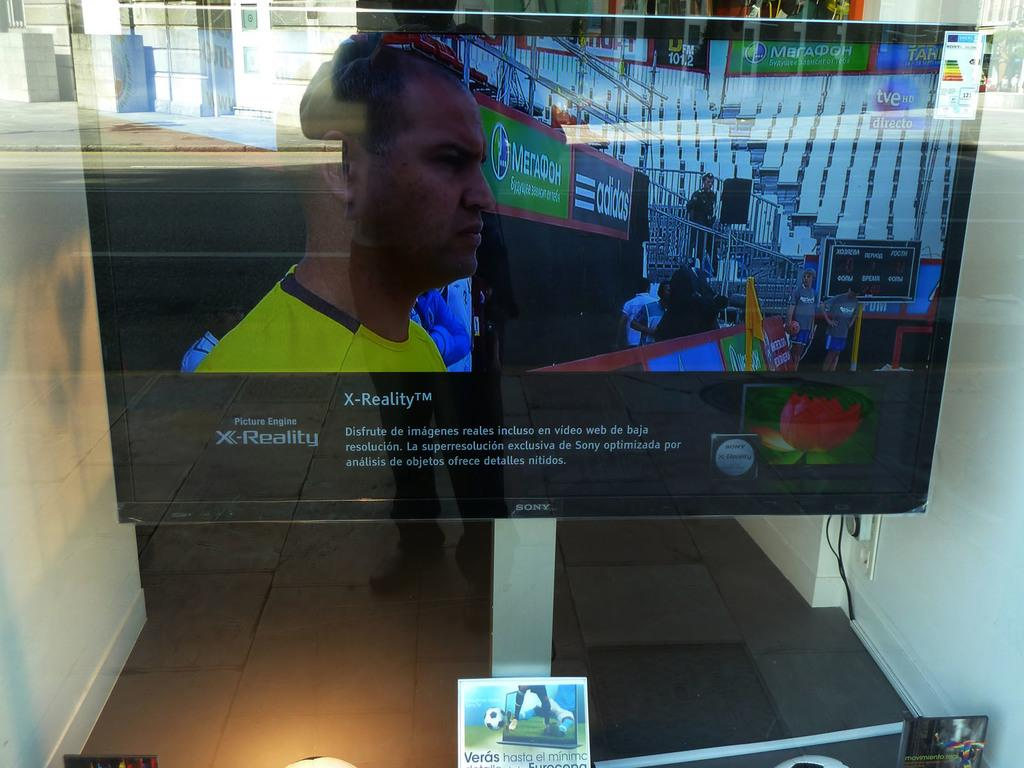<image>
Write a terse but informative summary of the picture. A monitor is sitting on a table with the words Picture Engine X-Reality on the screen. 